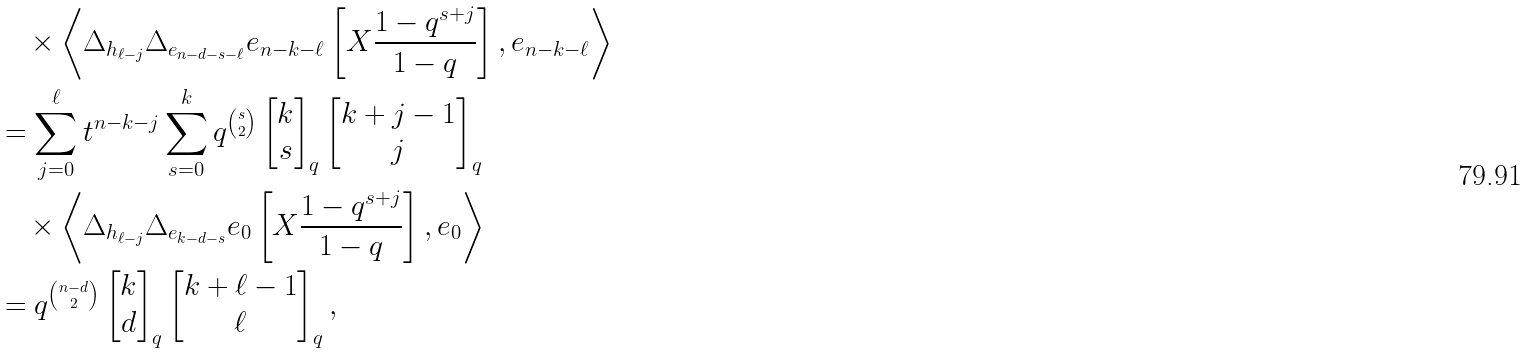<formula> <loc_0><loc_0><loc_500><loc_500>& \quad \times \left \langle \Delta _ { h _ { \ell - j } } \Delta _ { e _ { n - d - s - \ell } } e _ { n - k - \ell } \left [ X \frac { 1 - q ^ { s + j } } { 1 - q } \right ] , e _ { n - k - \ell } \right \rangle \\ & = \sum _ { j = 0 } ^ { \ell } t ^ { n - k - j } \sum _ { s = 0 } ^ { k } q ^ { \binom { s } { 2 } } \begin{bmatrix} k \\ s \end{bmatrix} _ { q } \begin{bmatrix} k + j - 1 \\ j \end{bmatrix} _ { q } \\ & \quad \times \left \langle \Delta _ { h _ { \ell - j } } \Delta _ { e _ { k - d - s } } e _ { 0 } \left [ X \frac { 1 - q ^ { s + j } } { 1 - q } \right ] , e _ { 0 } \right \rangle \\ & = q ^ { \binom { n - d } { 2 } } \begin{bmatrix} k \\ d \end{bmatrix} _ { q } \begin{bmatrix} k + \ell - 1 \\ \ell \end{bmatrix} _ { q } ,</formula> 